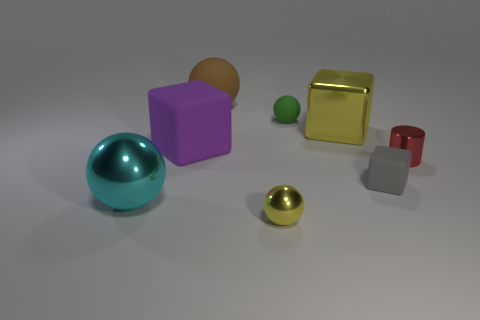Subtract all red spheres. Subtract all brown cylinders. How many spheres are left? 4 Add 1 big yellow matte balls. How many objects exist? 9 Subtract all cylinders. How many objects are left? 7 Subtract all metal things. Subtract all rubber objects. How many objects are left? 0 Add 2 big cyan metallic balls. How many big cyan metallic balls are left? 3 Add 8 yellow cubes. How many yellow cubes exist? 9 Subtract 0 blue blocks. How many objects are left? 8 